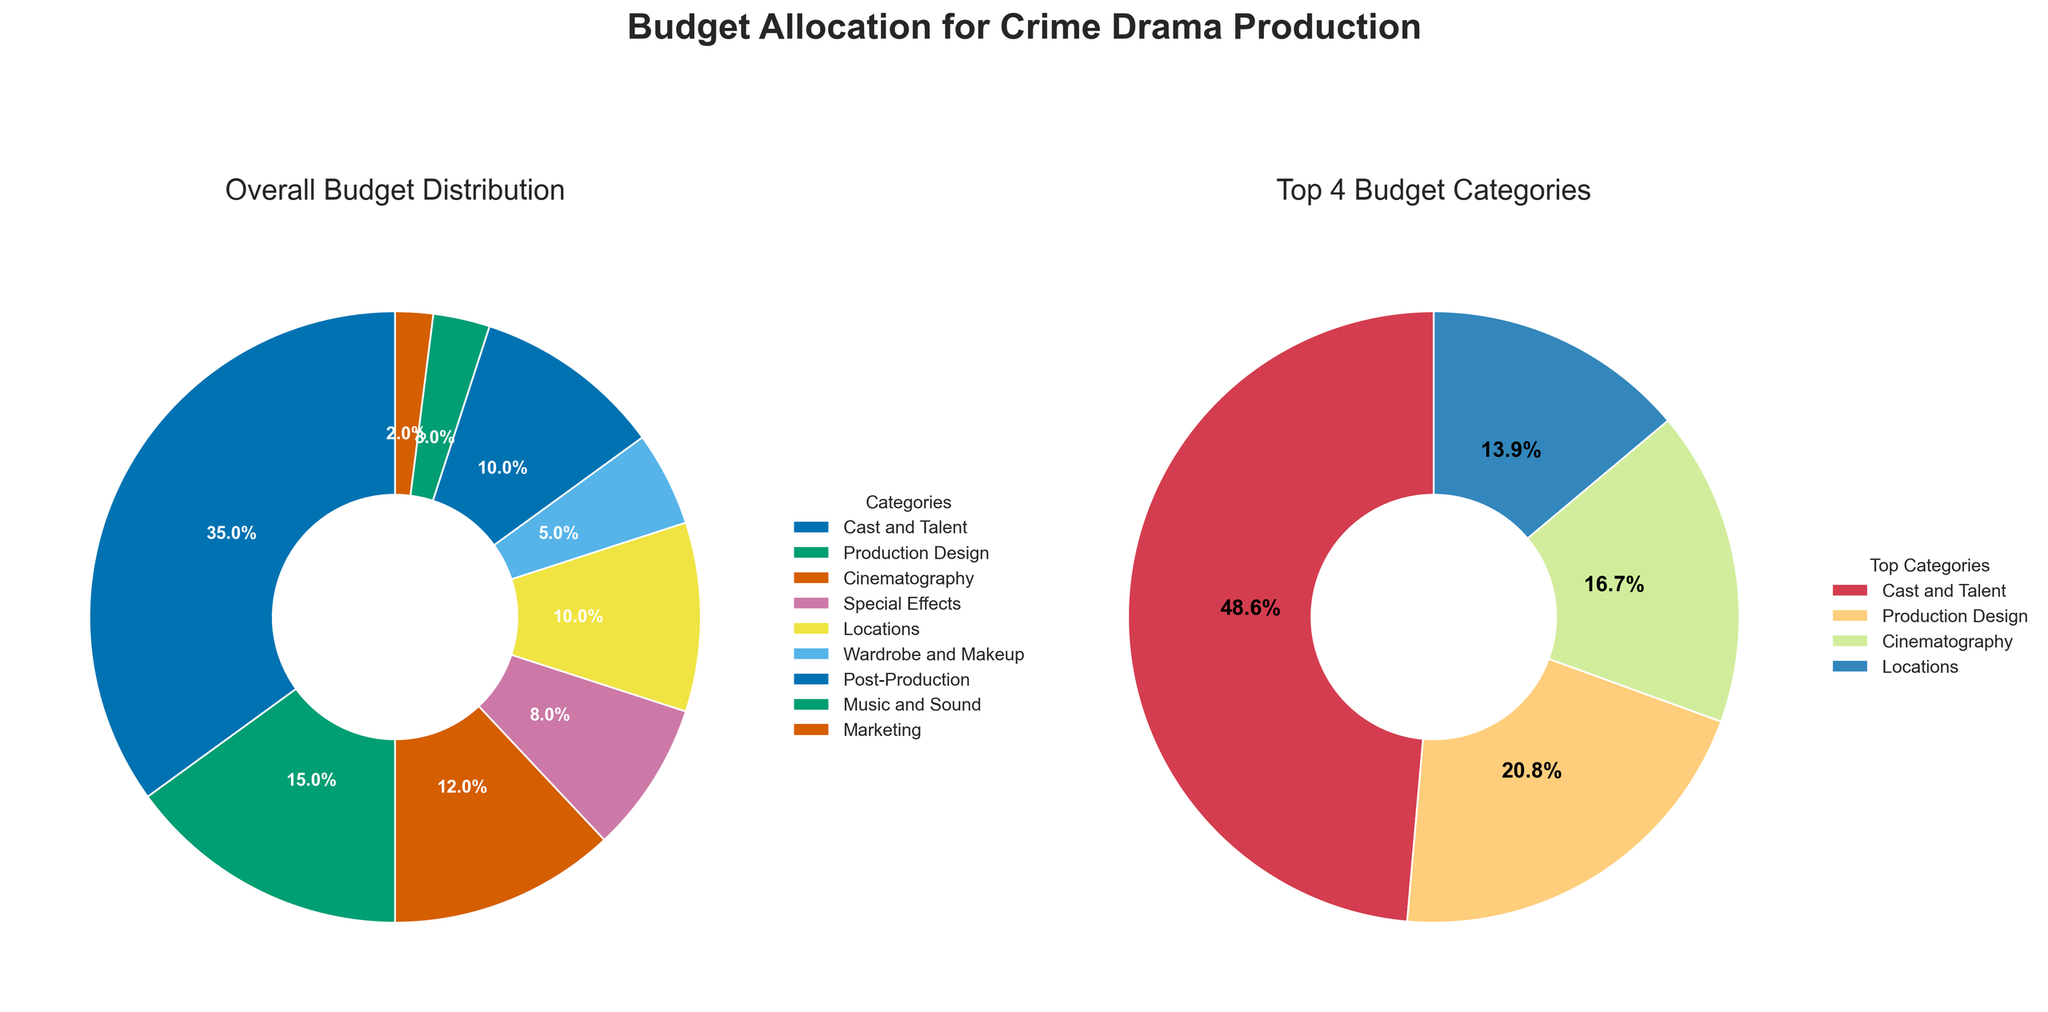What is the largest budget category in the overall budget distribution? The largest segment can be determined by looking at the main pie chart and finding the segment with the largest proportional area and percentage label. The main pie chart shows that "Cast and Talent" is the largest category, making up 35% of the budget.
Answer: Cast and Talent How many categories are allocated exactly 10% of the budget in the overall distribution? To find the number of categories with exactly 10% allocation, we look at the percentages shown in the main pie chart. Both "Locations" and "Post-Production" have a 10% budget allocation.
Answer: 2 categories Which category has the smallest budget allocation in the overall distribution? To determine the smallest allocation, look for the segment in the main pie chart with the smallest proportional area and percentage. The smallest segment is "Marketing," which makes up 2% of the budget.
Answer: Marketing What percentage of the overall budget is allocated to the top 4 categories combined? In the secondary donut chart displaying the top 4 categories, add the percentages of "Cast and Talent," "Production Design," "Cinematography," and "Locations." These are 35%, 15%, 12%, and 10%, respectively. The sum is 72%.
Answer: 72% How does the budget allocation for "Music and Sound" compare to "Special Effects"? Check the percentages for "Music and Sound" and "Special Effects" in the main pie chart. "Music and Sound" is allocated 3%, while "Special Effects" is allocated 8%. Thus, the allocation for "Music and Sound" is less than "Special Effects."
Answer: Music and Sound is less What is the combined budget allocation for "Wardrobe and Makeup" and "Marketing"? To find the combined allocation for "Wardrobe and Makeup" and "Marketing," add their percentages from the main pie chart. "Wardrobe and Makeup" is 5% and "Marketing" is 2%, giving a total of 7%.
Answer: 7% What category occupies the second-largest portion of the budget in the top 4 categories? Examine the secondary donut chart and identify the second-largest category. "Production Design" is the second-largest category within the top 4, with 15%.
Answer: Production Design Which two categories in the overall distribution have the same budget allocation? Look at the percentages in the main pie chart and find categories with equal values. Both "Post-Production" and "Locations" have 10% allocation each.
Answer: Post-Production and Locations In the top 4 budget categories, which category follows "Cinematography" in terms of budget allocation? Refer to the donut chart to find the category that follows "Cinematography" (12%) in the budget allocation order. "Locations" (10%) comes next after "Cinematography."
Answer: Locations 